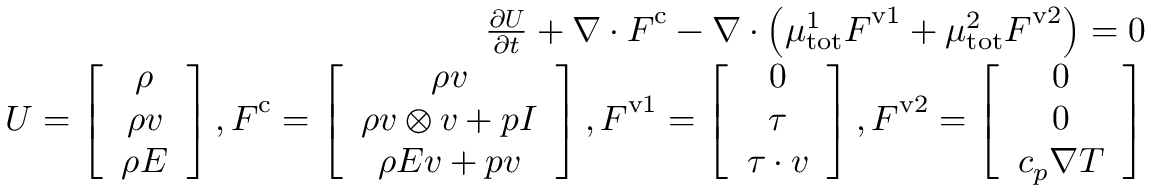Convert formula to latex. <formula><loc_0><loc_0><loc_500><loc_500>\begin{array} { r } { \frac { \partial U } { \partial t } + \nabla \cdot F ^ { c } - \nabla \cdot \left ( \mu _ { t o t } ^ { 1 } F ^ { v 1 } + \mu _ { t o t } ^ { 2 } F ^ { v 2 } \right ) = 0 } \\ { U = \left [ \begin{array} { c } { \rho } \\ { \rho v } \\ { \rho E } \end{array} \right ] , F ^ { c } = \left [ \begin{array} { c } { \rho v } \\ { \rho v \otimes v + p I } \\ { \rho E v + p v } \end{array} \right ] , F ^ { v 1 } = \left [ \begin{array} { c } { 0 } \\ { \tau } \\ { \tau \cdot v } \end{array} \right ] , F ^ { v 2 } = \left [ \begin{array} { c } { 0 } \\ { 0 } \\ { c _ { p } \nabla T } \end{array} \right ] } \end{array}</formula> 